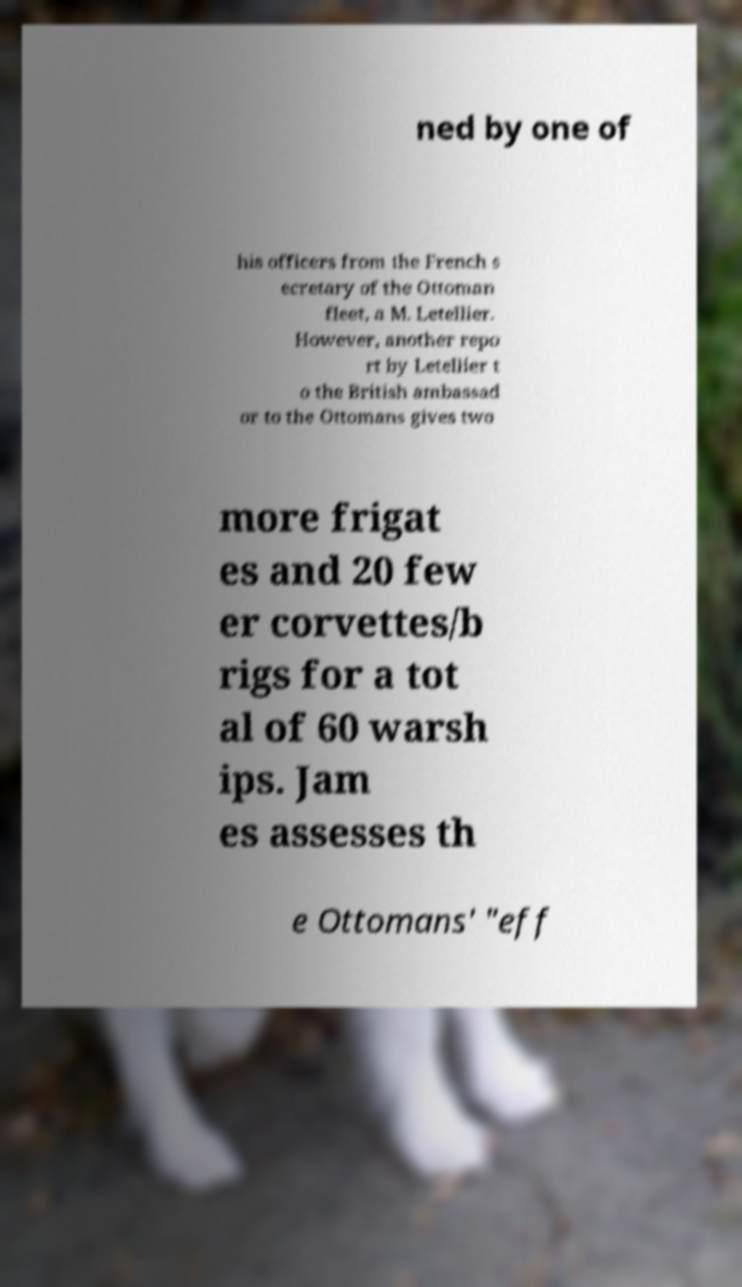I need the written content from this picture converted into text. Can you do that? ned by one of his officers from the French s ecretary of the Ottoman fleet, a M. Letellier. However, another repo rt by Letellier t o the British ambassad or to the Ottomans gives two more frigat es and 20 few er corvettes/b rigs for a tot al of 60 warsh ips. Jam es assesses th e Ottomans' "eff 